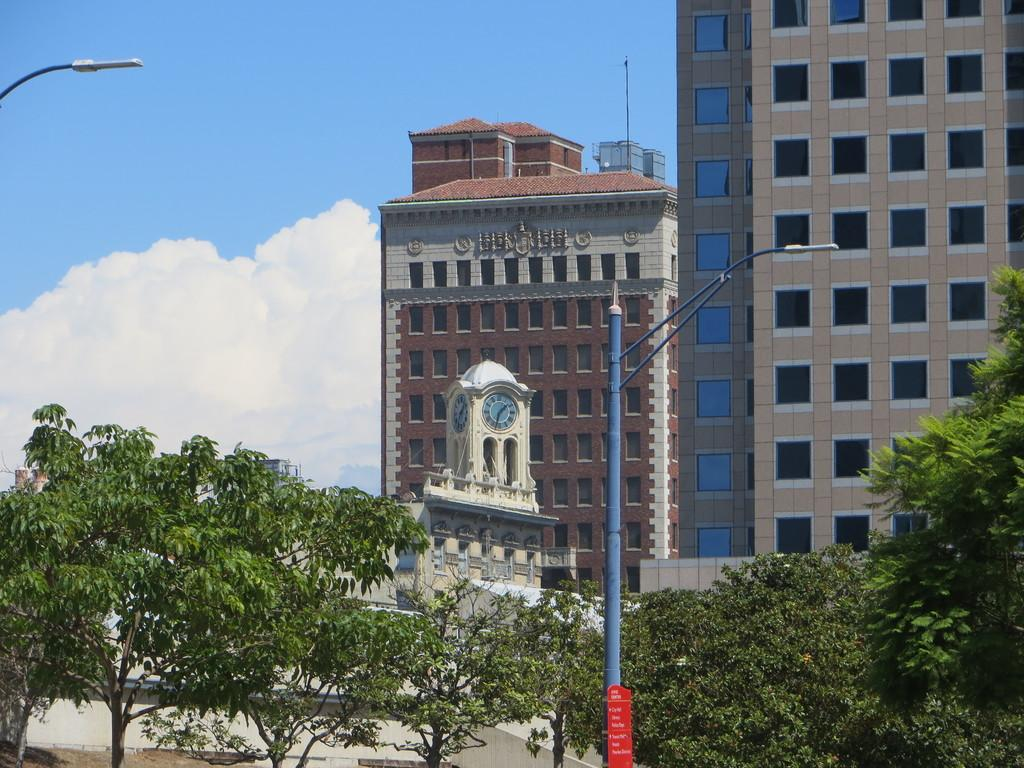What type of natural vegetation is visible in the image? There are trees in the image. What type of man-made structures can be seen in the image? There are poles and buildings visible in the image. What type of timekeeping devices are present in the image? There are clocks in the image. What can be seen in the sky in the image? There are clouds in the image. Can you tell me how many rabbits are hiding behind the trees in the image? There are no rabbits present in the image; it features trees, poles, buildings, clocks, and clouds. What type of engine is powering the buildings in the image? The image does not show any engines or indicate how the buildings are powered. 